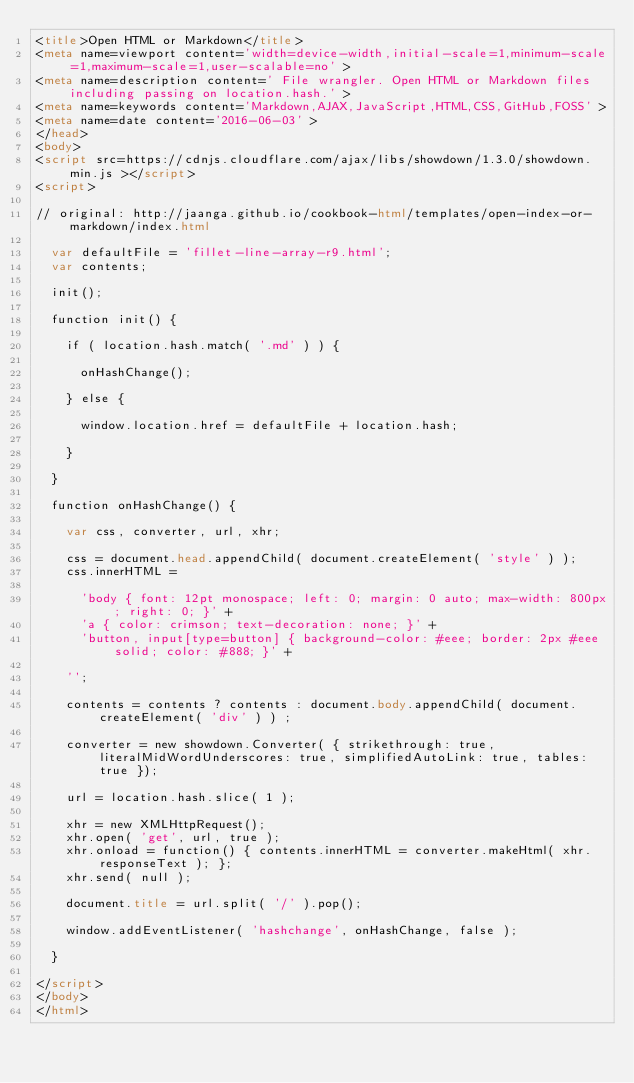<code> <loc_0><loc_0><loc_500><loc_500><_HTML_><title>Open HTML or Markdown</title>
<meta name=viewport content='width=device-width,initial-scale=1,minimum-scale=1,maximum-scale=1,user-scalable=no' >
<meta name=description content=' File wrangler. Open HTML or Markdown files including passing on location.hash.' >
<meta name=keywords content='Markdown,AJAX,JavaScript,HTML,CSS,GitHub,FOSS' >
<meta name=date content='2016-06-03' >
</head>
<body>
<script src=https://cdnjs.cloudflare.com/ajax/libs/showdown/1.3.0/showdown.min.js ></script>
<script>

// original: http://jaanga.github.io/cookbook-html/templates/open-index-or-markdown/index.html

	var defaultFile = 'fillet-line-array-r9.html';
	var contents;

	init();

	function init() {

		if ( location.hash.match( '.md' ) ) {

			onHashChange();

		} else {

			window.location.href = defaultFile + location.hash;

		}

	}

	function onHashChange() {

		var css, converter, url, xhr;

		css = document.head.appendChild( document.createElement( 'style' ) );
		css.innerHTML =

			'body { font: 12pt monospace; left: 0; margin: 0 auto; max-width: 800px; right: 0; }' +
			'a { color: crimson; text-decoration: none; }' +
			'button, input[type=button] { background-color: #eee; border: 2px #eee solid; color: #888; }' +

		'';

		contents = contents ? contents : document.body.appendChild( document.createElement( 'div' ) ) ;

		converter = new showdown.Converter( { strikethrough: true, literalMidWordUnderscores: true, simplifiedAutoLink: true, tables: true });

		url = location.hash.slice( 1 );

		xhr = new XMLHttpRequest();
		xhr.open( 'get', url, true );
		xhr.onload = function() { contents.innerHTML = converter.makeHtml( xhr.responseText ); };
		xhr.send( null );

		document.title = url.split( '/' ).pop();

		window.addEventListener( 'hashchange', onHashChange, false );

	}

</script>
</body>
</html>
</code> 